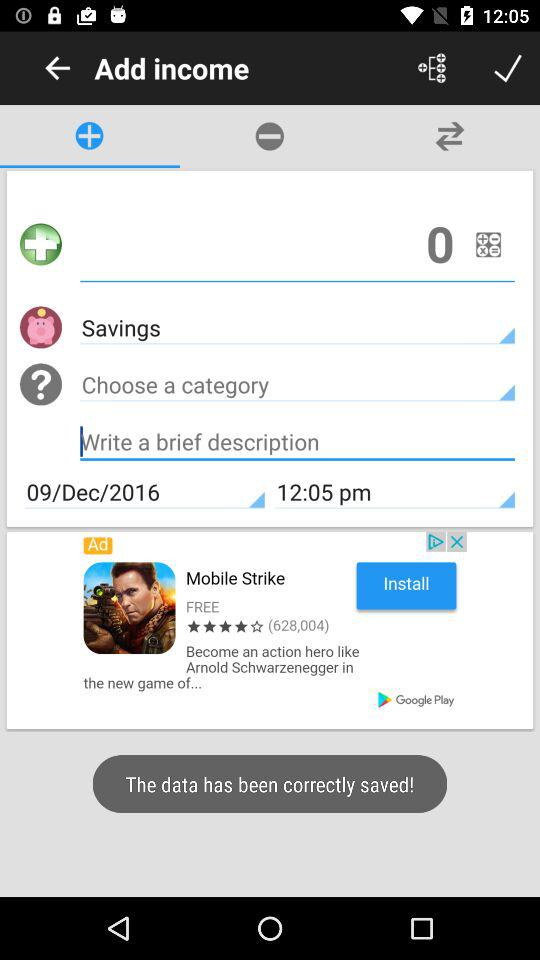How much is added?
When the provided information is insufficient, respond with <no answer>. <no answer> 